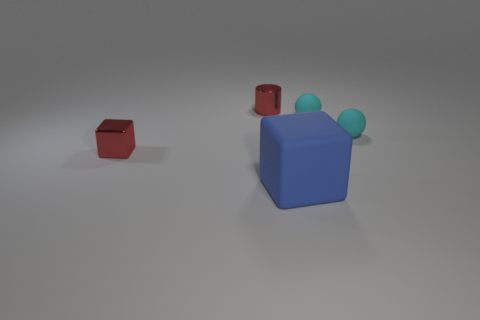Subtract all blue cubes. How many cubes are left? 1 Add 4 yellow things. How many objects exist? 9 Subtract all cylinders. How many objects are left? 4 Add 3 cyan balls. How many cyan balls exist? 5 Subtract 0 purple balls. How many objects are left? 5 Subtract all gray cylinders. Subtract all cyan spheres. How many objects are left? 3 Add 2 rubber balls. How many rubber balls are left? 4 